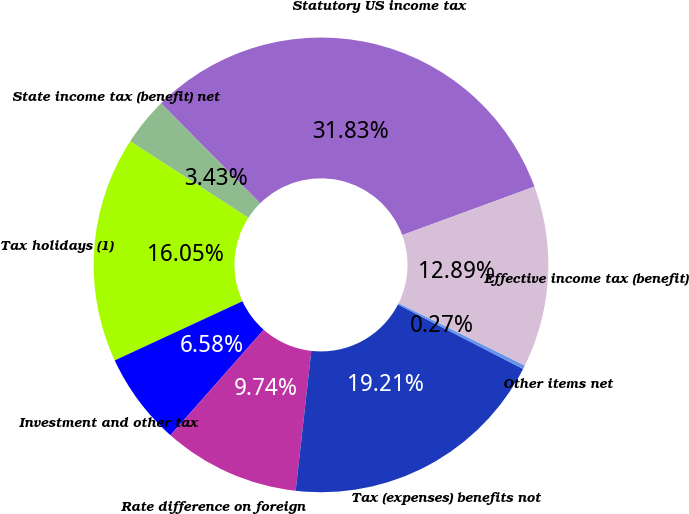Convert chart to OTSL. <chart><loc_0><loc_0><loc_500><loc_500><pie_chart><fcel>Statutory US income tax<fcel>State income tax (benefit) net<fcel>Tax holidays (1)<fcel>Investment and other tax<fcel>Rate difference on foreign<fcel>Tax (expenses) benefits not<fcel>Other items net<fcel>Effective income tax (benefit)<nl><fcel>31.83%<fcel>3.43%<fcel>16.05%<fcel>6.58%<fcel>9.74%<fcel>19.21%<fcel>0.27%<fcel>12.89%<nl></chart> 